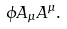<formula> <loc_0><loc_0><loc_500><loc_500>\phi A _ { \mu } A ^ { \mu } .</formula> 